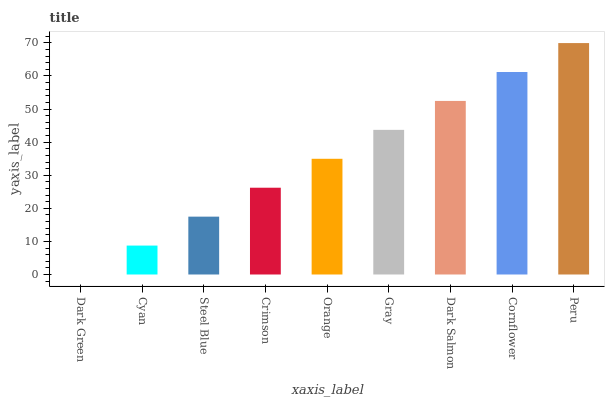Is Dark Green the minimum?
Answer yes or no. Yes. Is Peru the maximum?
Answer yes or no. Yes. Is Cyan the minimum?
Answer yes or no. No. Is Cyan the maximum?
Answer yes or no. No. Is Cyan greater than Dark Green?
Answer yes or no. Yes. Is Dark Green less than Cyan?
Answer yes or no. Yes. Is Dark Green greater than Cyan?
Answer yes or no. No. Is Cyan less than Dark Green?
Answer yes or no. No. Is Orange the high median?
Answer yes or no. Yes. Is Orange the low median?
Answer yes or no. Yes. Is Cyan the high median?
Answer yes or no. No. Is Crimson the low median?
Answer yes or no. No. 